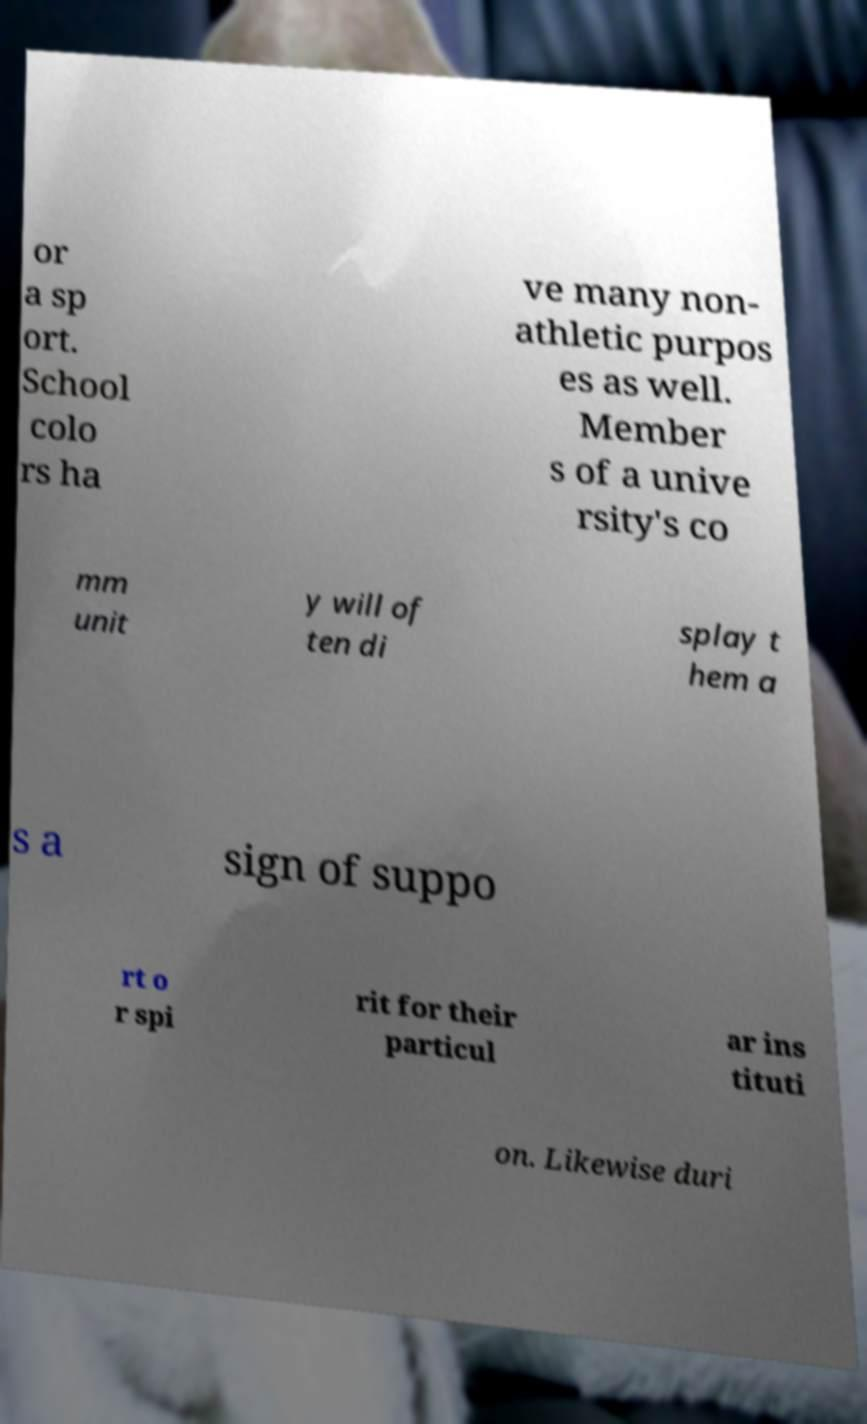For documentation purposes, I need the text within this image transcribed. Could you provide that? or a sp ort. School colo rs ha ve many non- athletic purpos es as well. Member s of a unive rsity's co mm unit y will of ten di splay t hem a s a sign of suppo rt o r spi rit for their particul ar ins tituti on. Likewise duri 